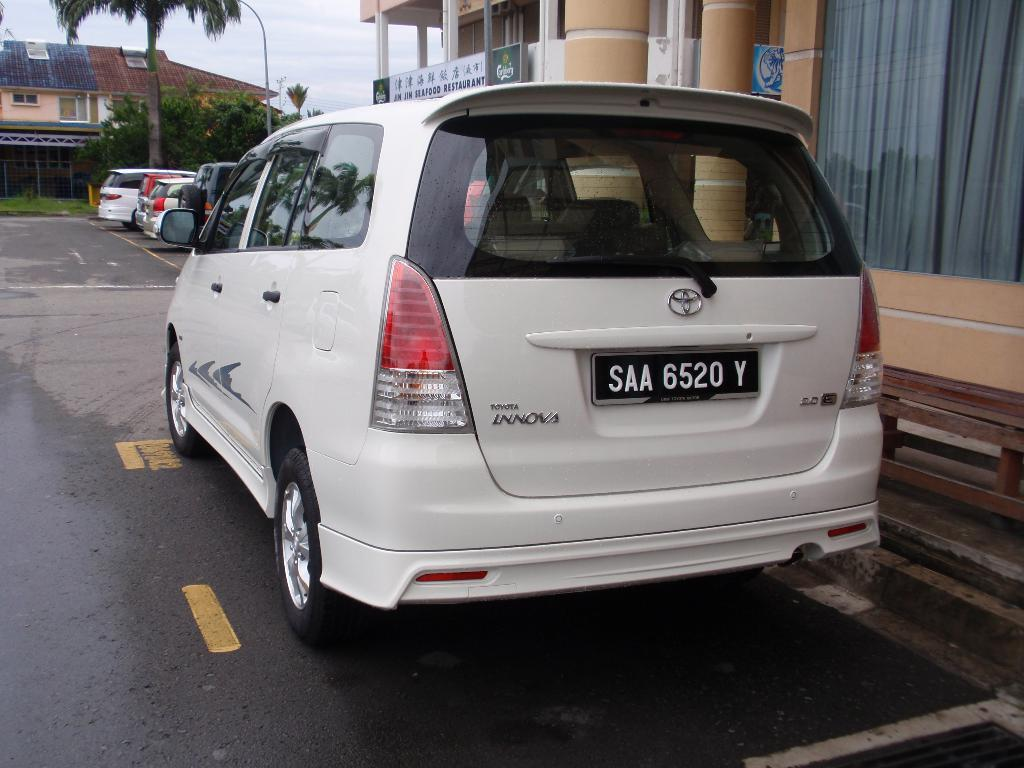Provide a one-sentence caption for the provided image. A Toyota minivan with a tag that reads SAA 6520 Y. 